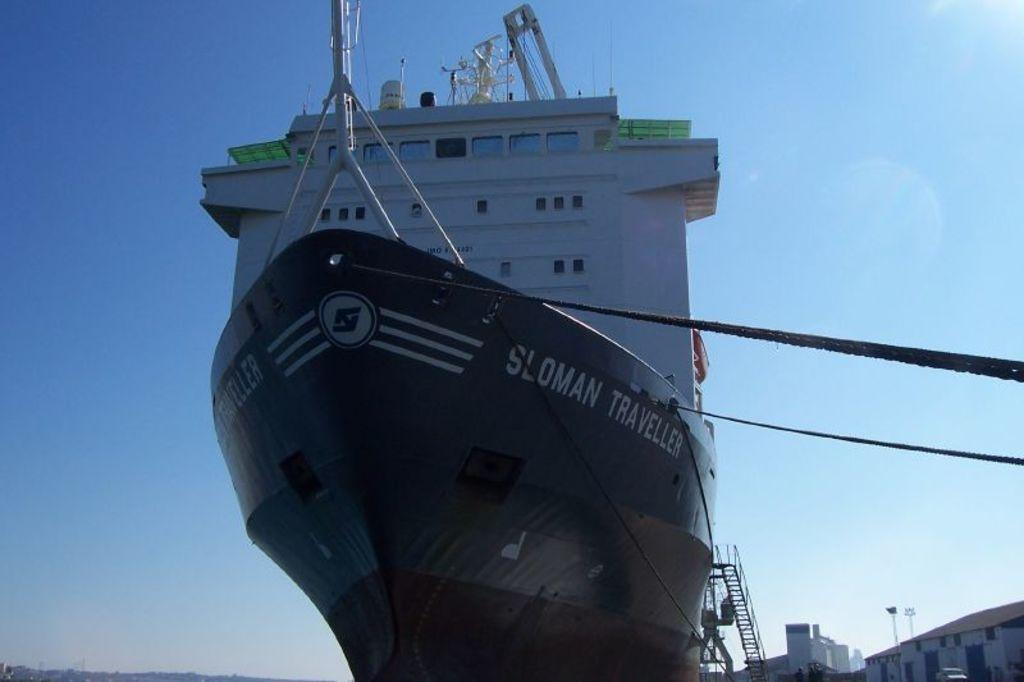What type of structure is present in the image? There is a boat house in the image. What is the color of the building inside the boat house? The building inside the boat house is white. What can be seen in the background of the image? There is a sky visible in the background of the image. Is there any blood visible on the boat house in the image? No, there is no blood visible on the boat house in the image. What type of pipe can be seen connecting the boat house to the water? There is no pipe visible connecting the boat house to the water in the image. 